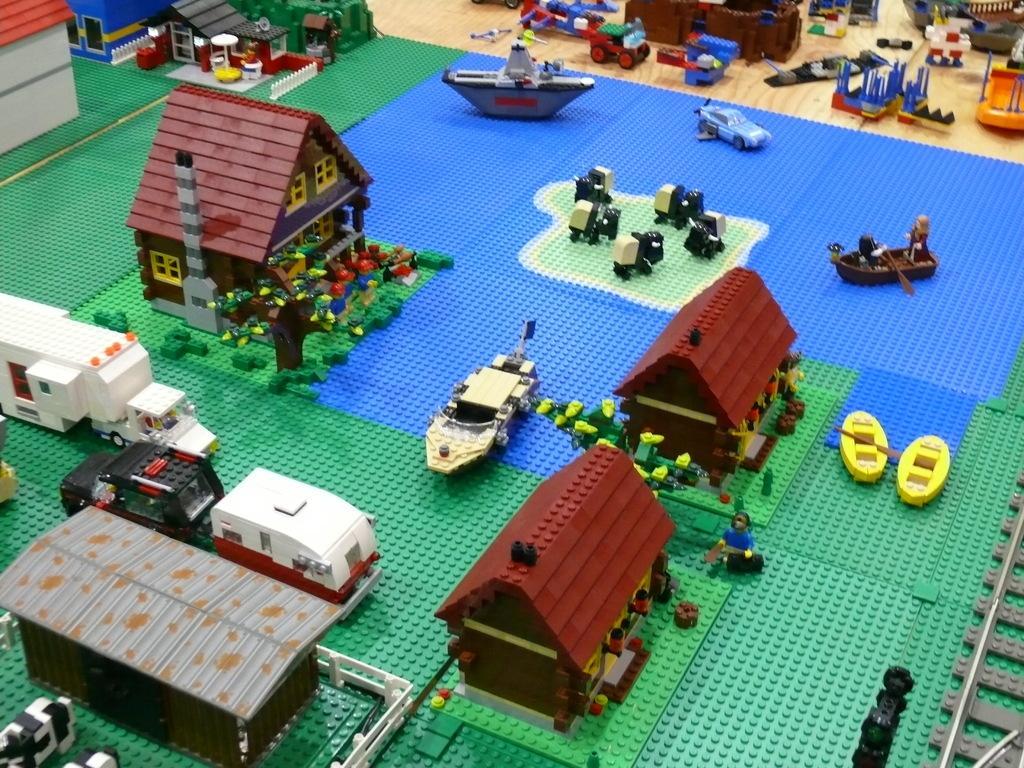Describe this image in one or two sentences. In this picture we can see the Lego and in the center we can see the houses, vehicles and the group of persons in the boat and we can see the group of persons, boats, vehicles and many other objects. 